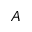Convert formula to latex. <formula><loc_0><loc_0><loc_500><loc_500>A</formula> 